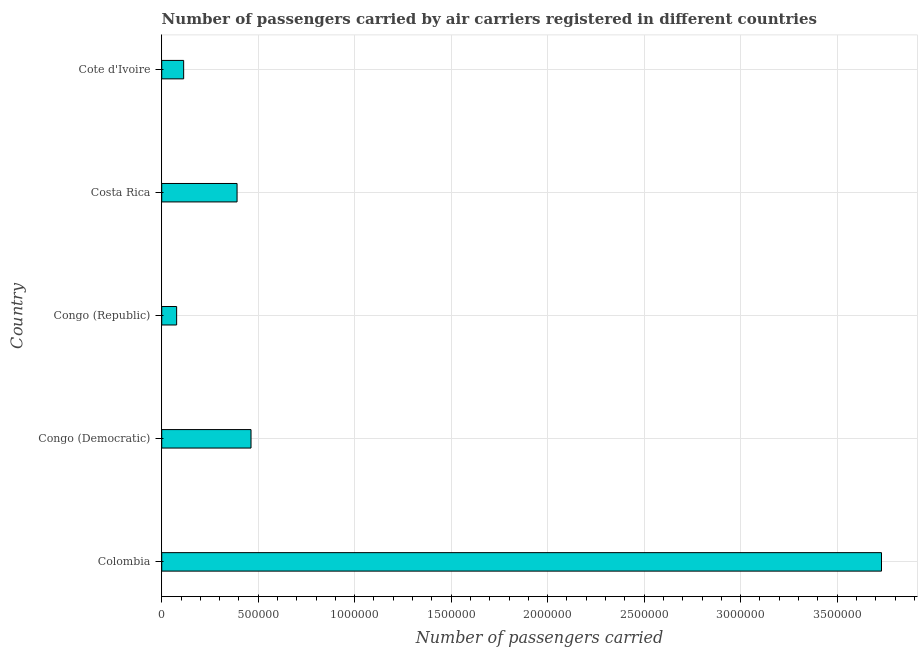Does the graph contain grids?
Your answer should be very brief. Yes. What is the title of the graph?
Your answer should be very brief. Number of passengers carried by air carriers registered in different countries. What is the label or title of the X-axis?
Offer a terse response. Number of passengers carried. What is the number of passengers carried in Congo (Republic)?
Provide a short and direct response. 7.74e+04. Across all countries, what is the maximum number of passengers carried?
Keep it short and to the point. 3.73e+06. Across all countries, what is the minimum number of passengers carried?
Give a very brief answer. 7.74e+04. In which country was the number of passengers carried minimum?
Provide a short and direct response. Congo (Republic). What is the sum of the number of passengers carried?
Your answer should be very brief. 4.77e+06. What is the difference between the number of passengers carried in Congo (Democratic) and Cote d'Ivoire?
Make the answer very short. 3.49e+05. What is the average number of passengers carried per country?
Offer a terse response. 9.55e+05. What is the median number of passengers carried?
Make the answer very short. 3.90e+05. What is the ratio of the number of passengers carried in Colombia to that in Cote d'Ivoire?
Your answer should be very brief. 32.81. Is the number of passengers carried in Congo (Democratic) less than that in Congo (Republic)?
Give a very brief answer. No. Is the difference between the number of passengers carried in Congo (Republic) and Costa Rica greater than the difference between any two countries?
Give a very brief answer. No. What is the difference between the highest and the second highest number of passengers carried?
Keep it short and to the point. 3.27e+06. Is the sum of the number of passengers carried in Congo (Democratic) and Cote d'Ivoire greater than the maximum number of passengers carried across all countries?
Make the answer very short. No. What is the difference between the highest and the lowest number of passengers carried?
Give a very brief answer. 3.65e+06. Are all the bars in the graph horizontal?
Your response must be concise. Yes. How many countries are there in the graph?
Keep it short and to the point. 5. Are the values on the major ticks of X-axis written in scientific E-notation?
Offer a very short reply. No. What is the Number of passengers carried in Colombia?
Provide a succinct answer. 3.73e+06. What is the Number of passengers carried of Congo (Democratic)?
Make the answer very short. 4.63e+05. What is the Number of passengers carried of Congo (Republic)?
Provide a succinct answer. 7.74e+04. What is the Number of passengers carried in Costa Rica?
Your response must be concise. 3.90e+05. What is the Number of passengers carried of Cote d'Ivoire?
Your response must be concise. 1.14e+05. What is the difference between the Number of passengers carried in Colombia and Congo (Democratic)?
Offer a very short reply. 3.27e+06. What is the difference between the Number of passengers carried in Colombia and Congo (Republic)?
Offer a terse response. 3.65e+06. What is the difference between the Number of passengers carried in Colombia and Costa Rica?
Your answer should be very brief. 3.34e+06. What is the difference between the Number of passengers carried in Colombia and Cote d'Ivoire?
Ensure brevity in your answer.  3.62e+06. What is the difference between the Number of passengers carried in Congo (Democratic) and Congo (Republic)?
Provide a short and direct response. 3.85e+05. What is the difference between the Number of passengers carried in Congo (Democratic) and Costa Rica?
Give a very brief answer. 7.23e+04. What is the difference between the Number of passengers carried in Congo (Democratic) and Cote d'Ivoire?
Provide a succinct answer. 3.49e+05. What is the difference between the Number of passengers carried in Congo (Republic) and Costa Rica?
Ensure brevity in your answer.  -3.13e+05. What is the difference between the Number of passengers carried in Congo (Republic) and Cote d'Ivoire?
Give a very brief answer. -3.63e+04. What is the difference between the Number of passengers carried in Costa Rica and Cote d'Ivoire?
Ensure brevity in your answer.  2.77e+05. What is the ratio of the Number of passengers carried in Colombia to that in Congo (Democratic)?
Give a very brief answer. 8.06. What is the ratio of the Number of passengers carried in Colombia to that in Congo (Republic)?
Give a very brief answer. 48.19. What is the ratio of the Number of passengers carried in Colombia to that in Costa Rica?
Provide a succinct answer. 9.55. What is the ratio of the Number of passengers carried in Colombia to that in Cote d'Ivoire?
Ensure brevity in your answer.  32.81. What is the ratio of the Number of passengers carried in Congo (Democratic) to that in Congo (Republic)?
Offer a terse response. 5.98. What is the ratio of the Number of passengers carried in Congo (Democratic) to that in Costa Rica?
Ensure brevity in your answer.  1.19. What is the ratio of the Number of passengers carried in Congo (Democratic) to that in Cote d'Ivoire?
Your response must be concise. 4.07. What is the ratio of the Number of passengers carried in Congo (Republic) to that in Costa Rica?
Offer a very short reply. 0.2. What is the ratio of the Number of passengers carried in Congo (Republic) to that in Cote d'Ivoire?
Your answer should be compact. 0.68. What is the ratio of the Number of passengers carried in Costa Rica to that in Cote d'Ivoire?
Your answer should be compact. 3.43. 